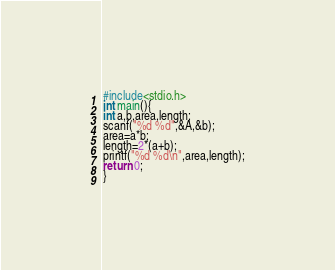Convert code to text. <code><loc_0><loc_0><loc_500><loc_500><_C_>#include<stdio.h>
int main(){
int a,b,area,length;
scanf("%d %d",&A,&b);
area=a*b;
length=2*(a+b);
printf("%d %d\n",area,length);
return 0;
}</code> 